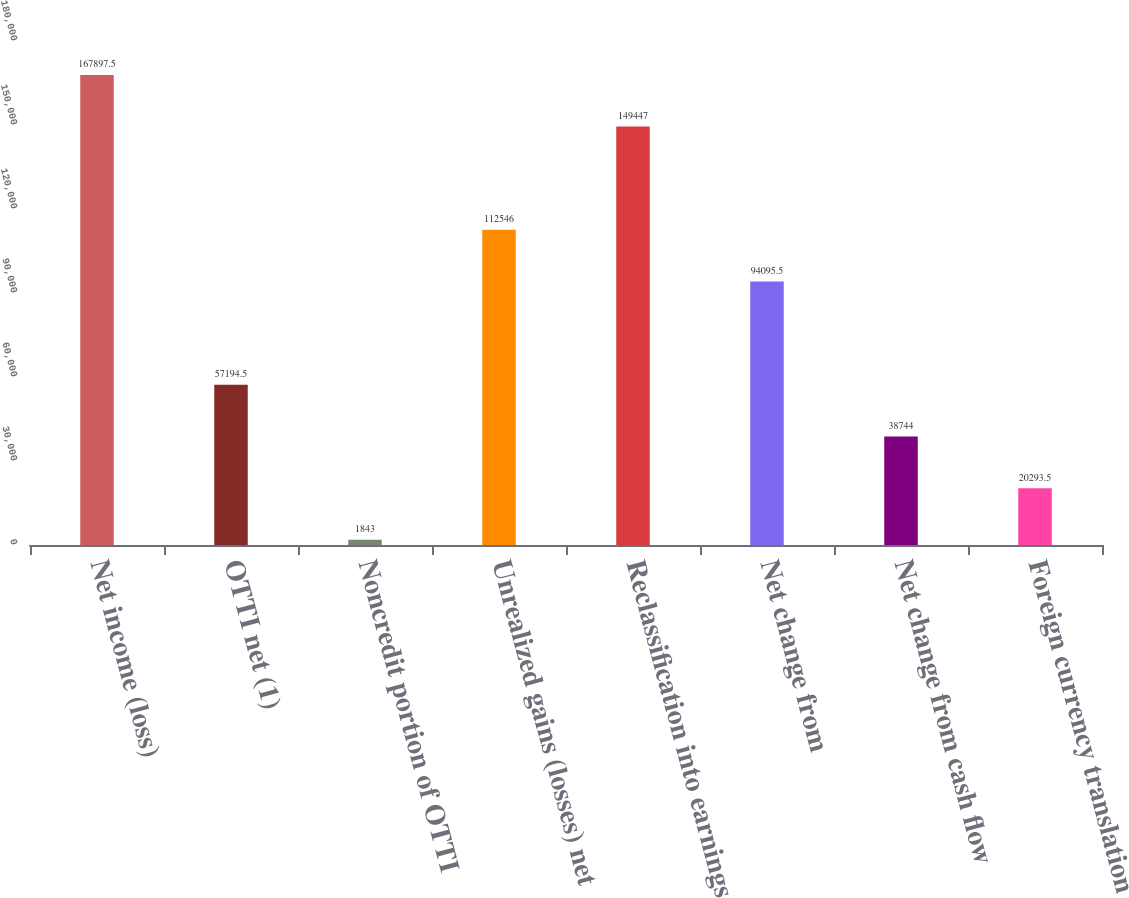Convert chart to OTSL. <chart><loc_0><loc_0><loc_500><loc_500><bar_chart><fcel>Net income (loss)<fcel>OTTI net (1)<fcel>Noncredit portion of OTTI<fcel>Unrealized gains (losses) net<fcel>Reclassification into earnings<fcel>Net change from<fcel>Net change from cash flow<fcel>Foreign currency translation<nl><fcel>167898<fcel>57194.5<fcel>1843<fcel>112546<fcel>149447<fcel>94095.5<fcel>38744<fcel>20293.5<nl></chart> 